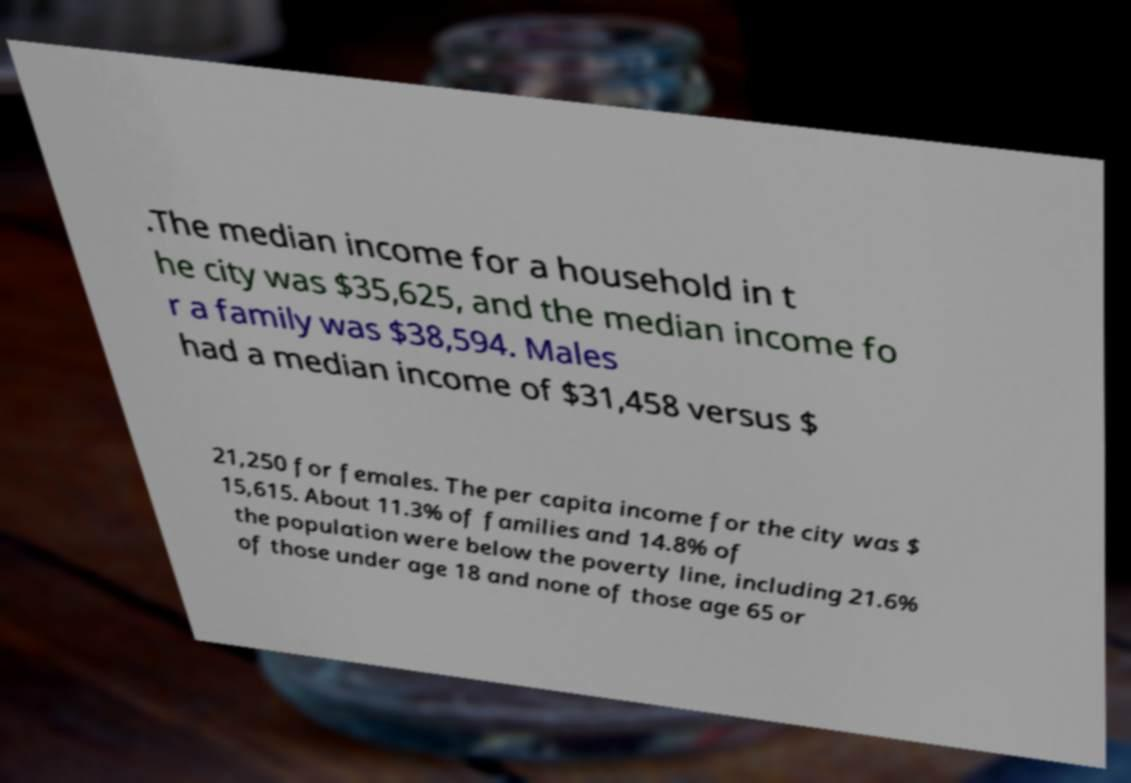Could you extract and type out the text from this image? .The median income for a household in t he city was $35,625, and the median income fo r a family was $38,594. Males had a median income of $31,458 versus $ 21,250 for females. The per capita income for the city was $ 15,615. About 11.3% of families and 14.8% of the population were below the poverty line, including 21.6% of those under age 18 and none of those age 65 or 